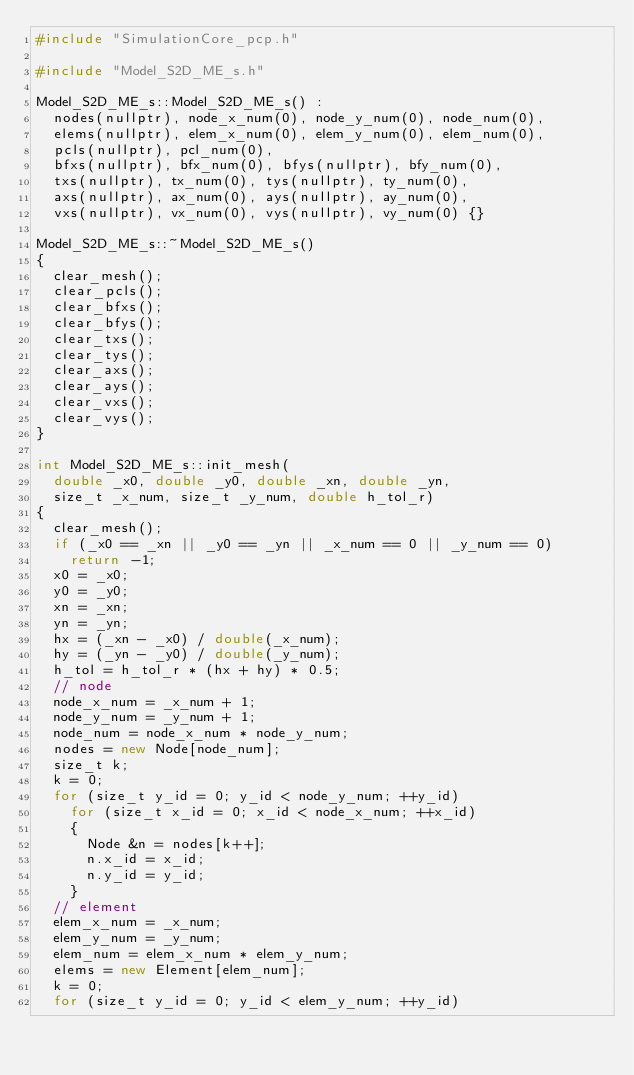Convert code to text. <code><loc_0><loc_0><loc_500><loc_500><_C++_>#include "SimulationCore_pcp.h"

#include "Model_S2D_ME_s.h"

Model_S2D_ME_s::Model_S2D_ME_s() :
	nodes(nullptr), node_x_num(0), node_y_num(0), node_num(0),
	elems(nullptr), elem_x_num(0), elem_y_num(0), elem_num(0),
	pcls(nullptr), pcl_num(0),
	bfxs(nullptr), bfx_num(0), bfys(nullptr), bfy_num(0),
	txs(nullptr), tx_num(0), tys(nullptr), ty_num(0),
	axs(nullptr), ax_num(0), ays(nullptr), ay_num(0),
	vxs(nullptr), vx_num(0), vys(nullptr), vy_num(0) {}

Model_S2D_ME_s::~Model_S2D_ME_s()
{
	clear_mesh();
	clear_pcls();
	clear_bfxs();
	clear_bfys();
	clear_txs();
	clear_tys();
	clear_axs();
	clear_ays();
	clear_vxs();
	clear_vys();
}

int Model_S2D_ME_s::init_mesh(
	double _x0, double _y0, double _xn, double _yn,
	size_t _x_num, size_t _y_num, double h_tol_r)
{
	clear_mesh();
	if (_x0 == _xn || _y0 == _yn || _x_num == 0 || _y_num == 0)
		return -1;
	x0 = _x0;
	y0 = _y0;
	xn = _xn;
	yn = _yn;
	hx = (_xn - _x0) / double(_x_num);
	hy = (_yn - _y0) / double(_y_num);
	h_tol = h_tol_r * (hx + hy) * 0.5;
	// node
	node_x_num = _x_num + 1;
	node_y_num = _y_num + 1;
	node_num = node_x_num * node_y_num;
	nodes = new Node[node_num];
	size_t k;
	k = 0;
	for (size_t y_id = 0; y_id < node_y_num; ++y_id)
		for (size_t x_id = 0; x_id < node_x_num; ++x_id)
		{
			Node &n = nodes[k++];
			n.x_id = x_id;
			n.y_id = y_id;
		}
	// element
	elem_x_num = _x_num;
	elem_y_num = _y_num;
	elem_num = elem_x_num * elem_y_num;
	elems = new Element[elem_num];
	k = 0;
	for (size_t y_id = 0; y_id < elem_y_num; ++y_id)</code> 